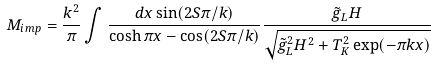Convert formula to latex. <formula><loc_0><loc_0><loc_500><loc_500>M _ { i m p } = \frac { k ^ { 2 } } { \pi } \int \frac { d x \sin ( 2 S \pi / k ) } { \cosh \pi x - \cos ( 2 S \pi / k ) } \frac { \tilde { g } _ { L } H } { \sqrt { { \tilde { g } _ { L } } ^ { 2 } H ^ { 2 } + T _ { K } ^ { 2 } \exp ( - \pi k x ) } }</formula> 